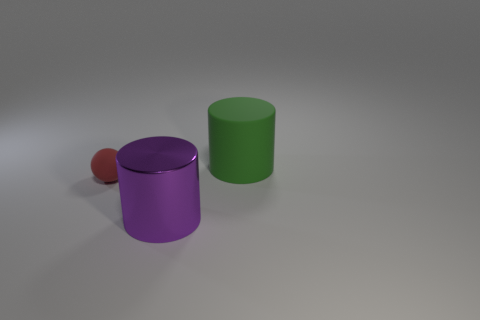Add 2 small balls. How many objects exist? 5 Subtract all red cylinders. Subtract all brown blocks. How many cylinders are left? 2 Subtract all purple blocks. How many purple spheres are left? 0 Subtract all red rubber things. Subtract all purple shiny cylinders. How many objects are left? 1 Add 1 large purple metal cylinders. How many large purple metal cylinders are left? 2 Add 2 purple metal things. How many purple metal things exist? 3 Subtract 0 yellow cylinders. How many objects are left? 3 Subtract all cylinders. How many objects are left? 1 